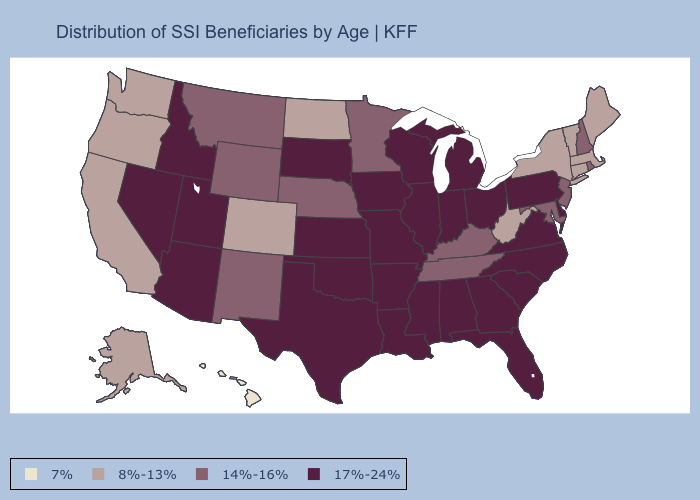What is the value of North Dakota?
Concise answer only. 8%-13%. What is the value of New Hampshire?
Answer briefly. 14%-16%. What is the highest value in states that border New Hampshire?
Write a very short answer. 8%-13%. Name the states that have a value in the range 14%-16%?
Quick response, please. Kentucky, Maryland, Minnesota, Montana, Nebraska, New Hampshire, New Jersey, New Mexico, Rhode Island, Tennessee, Wyoming. Among the states that border Ohio , which have the lowest value?
Quick response, please. West Virginia. Name the states that have a value in the range 8%-13%?
Write a very short answer. Alaska, California, Colorado, Connecticut, Maine, Massachusetts, New York, North Dakota, Oregon, Vermont, Washington, West Virginia. What is the value of Colorado?
Be succinct. 8%-13%. Does the first symbol in the legend represent the smallest category?
Answer briefly. Yes. What is the value of Missouri?
Short answer required. 17%-24%. Does North Dakota have the lowest value in the MidWest?
Quick response, please. Yes. Among the states that border Missouri , does Oklahoma have the lowest value?
Short answer required. No. Which states have the lowest value in the Northeast?
Concise answer only. Connecticut, Maine, Massachusetts, New York, Vermont. Which states have the highest value in the USA?
Write a very short answer. Alabama, Arizona, Arkansas, Delaware, Florida, Georgia, Idaho, Illinois, Indiana, Iowa, Kansas, Louisiana, Michigan, Mississippi, Missouri, Nevada, North Carolina, Ohio, Oklahoma, Pennsylvania, South Carolina, South Dakota, Texas, Utah, Virginia, Wisconsin. Does Hawaii have the highest value in the West?
Answer briefly. No. 